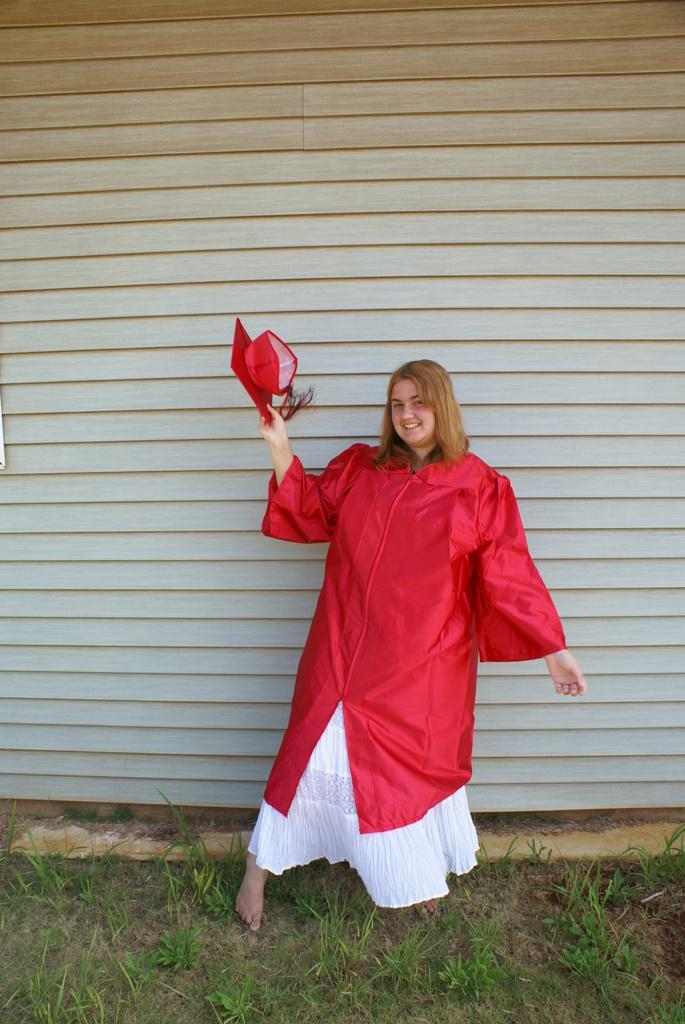What can be seen in the image? There is a person in the image. What is the person holding? The person is holding an object. What is the ground covered with? The ground is covered with grass. What is visible in the background of the image? There is a wall in the background of the image. What type of pest can be seen crawling on the wall in the image? There is no pest visible on the wall in the image. 